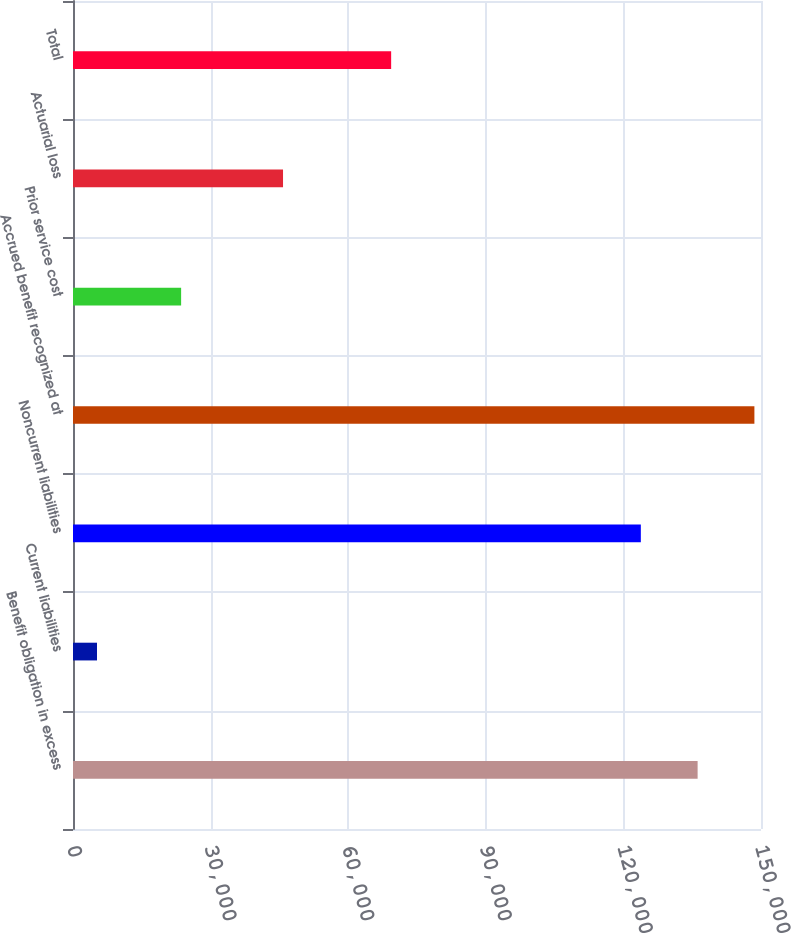<chart> <loc_0><loc_0><loc_500><loc_500><bar_chart><fcel>Benefit obligation in excess<fcel>Current liabilities<fcel>Noncurrent liabilities<fcel>Accrued benefit recognized at<fcel>Prior service cost<fcel>Actuarial loss<fcel>Total<nl><fcel>136181<fcel>5232<fcel>123801<fcel>148561<fcel>23573<fcel>45791<fcel>69364<nl></chart> 